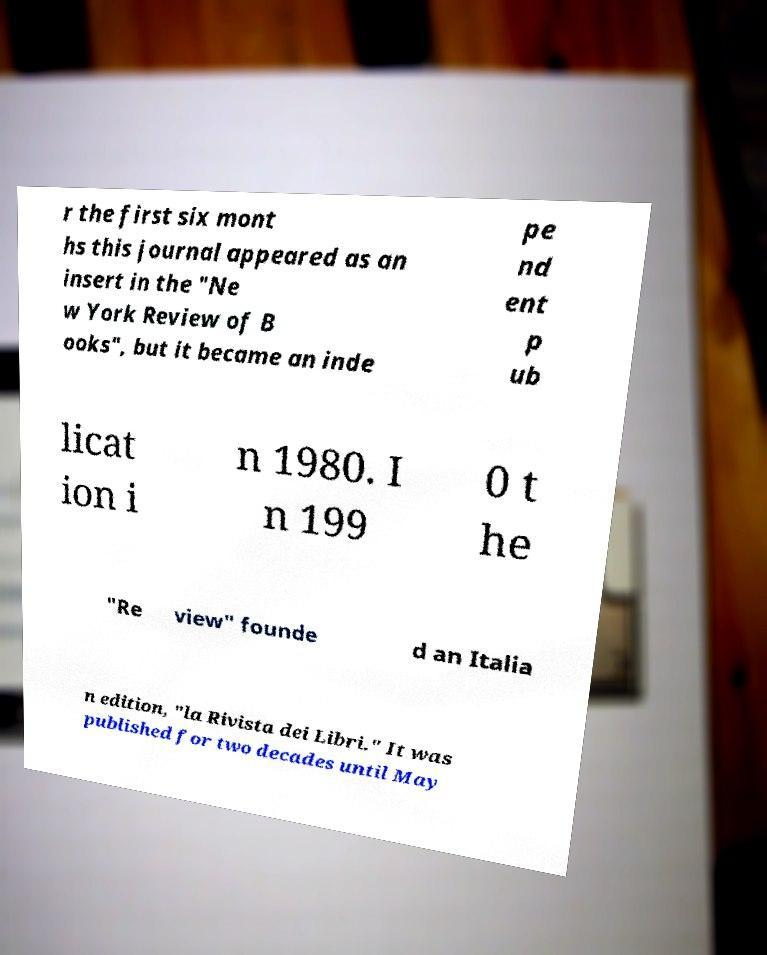There's text embedded in this image that I need extracted. Can you transcribe it verbatim? r the first six mont hs this journal appeared as an insert in the "Ne w York Review of B ooks", but it became an inde pe nd ent p ub licat ion i n 1980. I n 199 0 t he "Re view" founde d an Italia n edition, "la Rivista dei Libri." It was published for two decades until May 